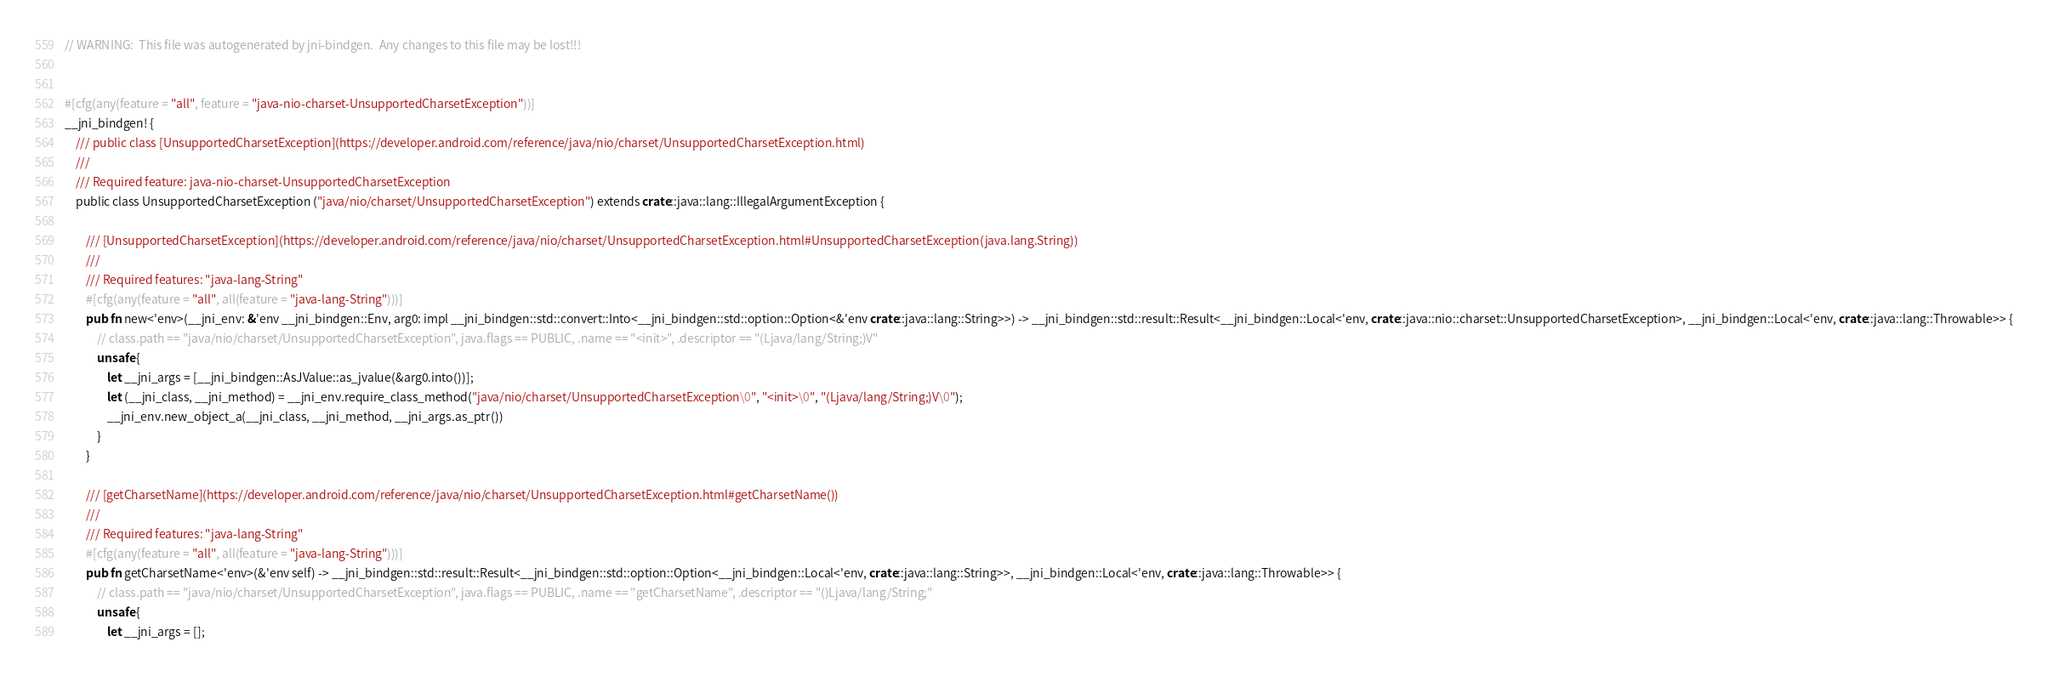<code> <loc_0><loc_0><loc_500><loc_500><_Rust_>// WARNING:  This file was autogenerated by jni-bindgen.  Any changes to this file may be lost!!!


#[cfg(any(feature = "all", feature = "java-nio-charset-UnsupportedCharsetException"))]
__jni_bindgen! {
    /// public class [UnsupportedCharsetException](https://developer.android.com/reference/java/nio/charset/UnsupportedCharsetException.html)
    ///
    /// Required feature: java-nio-charset-UnsupportedCharsetException
    public class UnsupportedCharsetException ("java/nio/charset/UnsupportedCharsetException") extends crate::java::lang::IllegalArgumentException {

        /// [UnsupportedCharsetException](https://developer.android.com/reference/java/nio/charset/UnsupportedCharsetException.html#UnsupportedCharsetException(java.lang.String))
        ///
        /// Required features: "java-lang-String"
        #[cfg(any(feature = "all", all(feature = "java-lang-String")))]
        pub fn new<'env>(__jni_env: &'env __jni_bindgen::Env, arg0: impl __jni_bindgen::std::convert::Into<__jni_bindgen::std::option::Option<&'env crate::java::lang::String>>) -> __jni_bindgen::std::result::Result<__jni_bindgen::Local<'env, crate::java::nio::charset::UnsupportedCharsetException>, __jni_bindgen::Local<'env, crate::java::lang::Throwable>> {
            // class.path == "java/nio/charset/UnsupportedCharsetException", java.flags == PUBLIC, .name == "<init>", .descriptor == "(Ljava/lang/String;)V"
            unsafe {
                let __jni_args = [__jni_bindgen::AsJValue::as_jvalue(&arg0.into())];
                let (__jni_class, __jni_method) = __jni_env.require_class_method("java/nio/charset/UnsupportedCharsetException\0", "<init>\0", "(Ljava/lang/String;)V\0");
                __jni_env.new_object_a(__jni_class, __jni_method, __jni_args.as_ptr())
            }
        }

        /// [getCharsetName](https://developer.android.com/reference/java/nio/charset/UnsupportedCharsetException.html#getCharsetName())
        ///
        /// Required features: "java-lang-String"
        #[cfg(any(feature = "all", all(feature = "java-lang-String")))]
        pub fn getCharsetName<'env>(&'env self) -> __jni_bindgen::std::result::Result<__jni_bindgen::std::option::Option<__jni_bindgen::Local<'env, crate::java::lang::String>>, __jni_bindgen::Local<'env, crate::java::lang::Throwable>> {
            // class.path == "java/nio/charset/UnsupportedCharsetException", java.flags == PUBLIC, .name == "getCharsetName", .descriptor == "()Ljava/lang/String;"
            unsafe {
                let __jni_args = [];</code> 